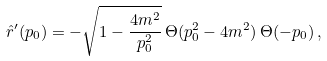<formula> <loc_0><loc_0><loc_500><loc_500>\hat { r } ^ { \prime } ( p _ { 0 } ) = - \sqrt { 1 - \frac { 4 m ^ { 2 } } { p _ { 0 } ^ { 2 } } } \, \Theta ( p _ { 0 } ^ { 2 } - 4 m ^ { 2 } ) \, \Theta ( - p _ { 0 } ) \, ,</formula> 